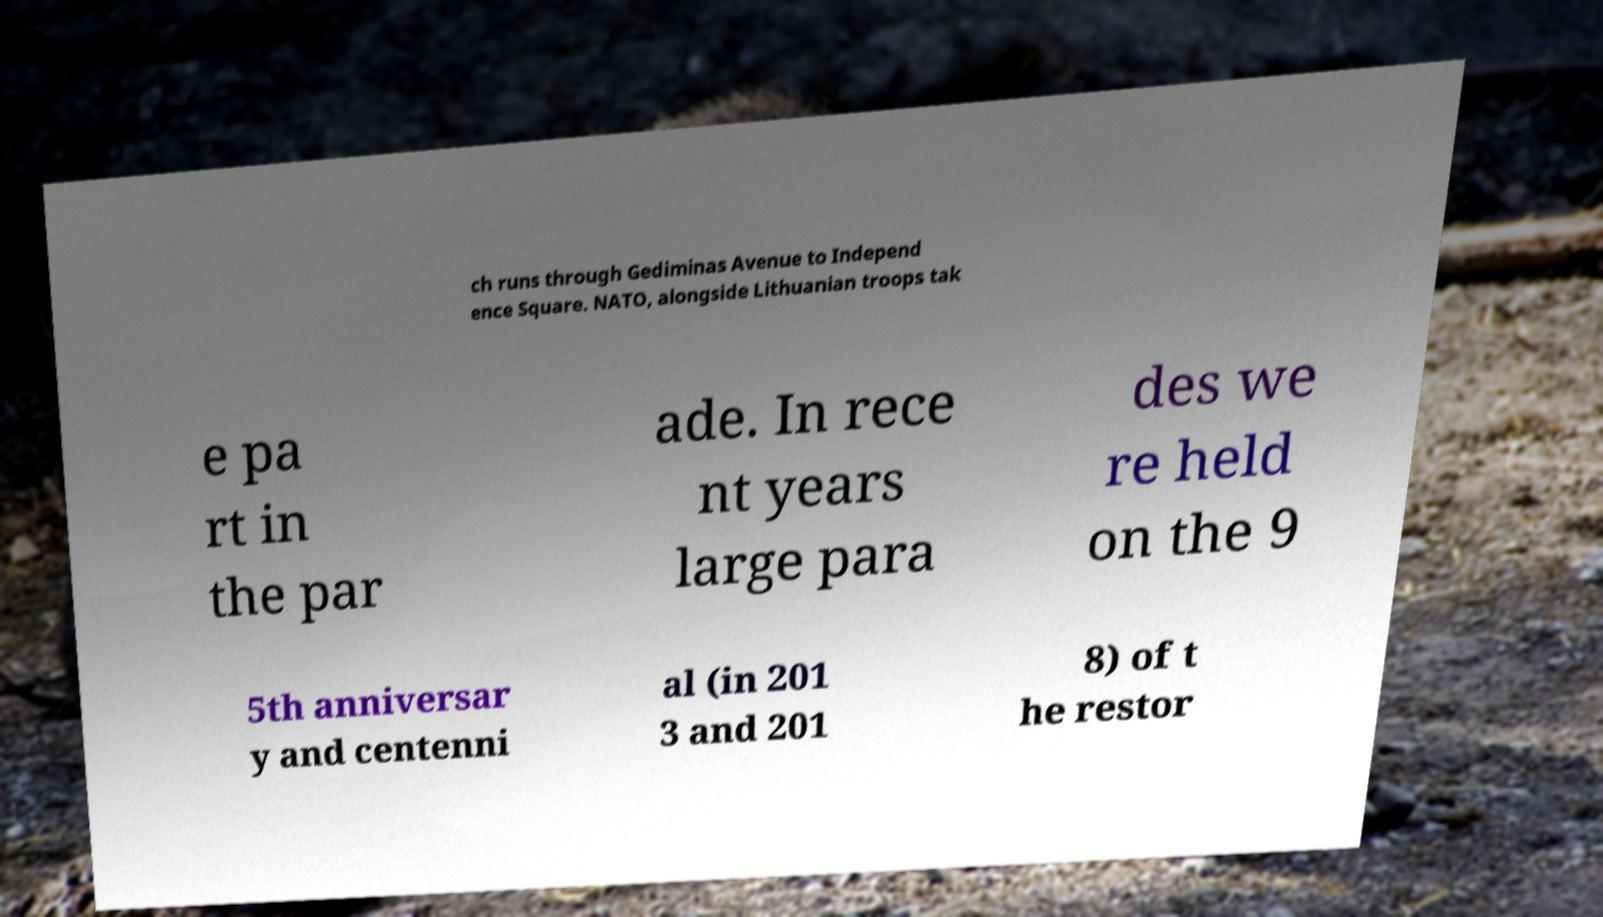Can you read and provide the text displayed in the image?This photo seems to have some interesting text. Can you extract and type it out for me? ch runs through Gediminas Avenue to Independ ence Square. NATO, alongside Lithuanian troops tak e pa rt in the par ade. In rece nt years large para des we re held on the 9 5th anniversar y and centenni al (in 201 3 and 201 8) of t he restor 